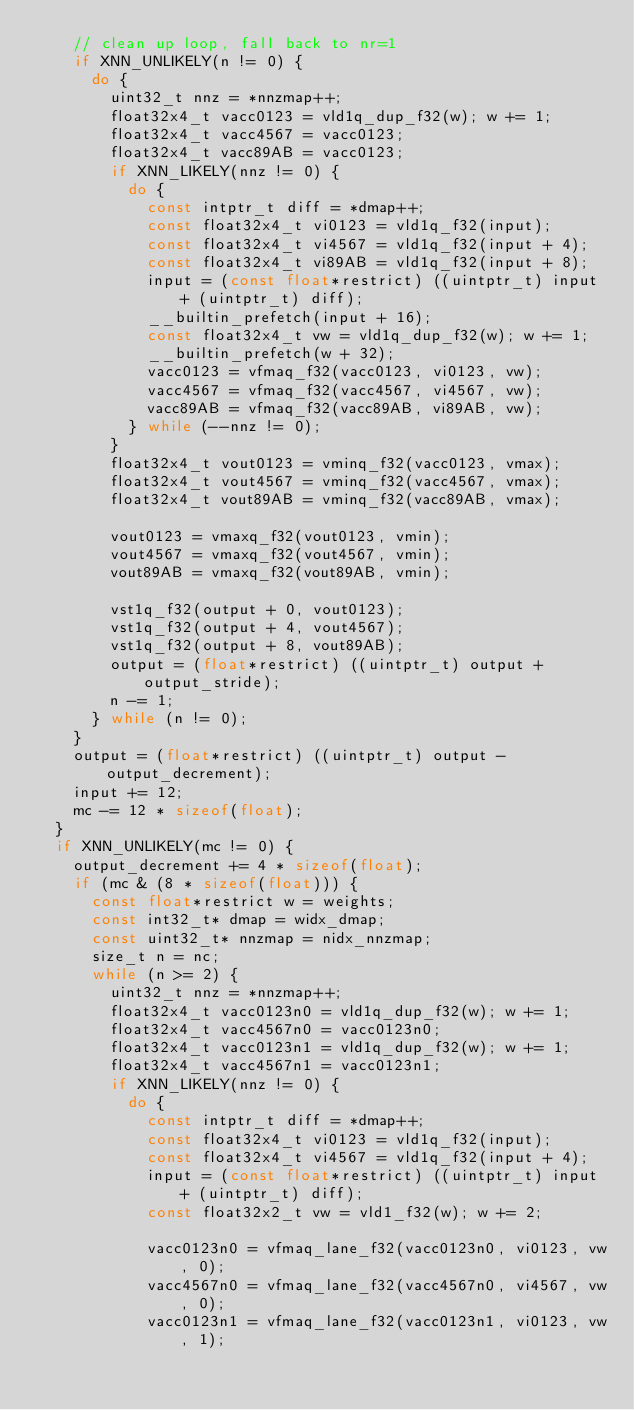Convert code to text. <code><loc_0><loc_0><loc_500><loc_500><_C_>    // clean up loop, fall back to nr=1
    if XNN_UNLIKELY(n != 0) {
      do {
        uint32_t nnz = *nnzmap++;
        float32x4_t vacc0123 = vld1q_dup_f32(w); w += 1;
        float32x4_t vacc4567 = vacc0123;
        float32x4_t vacc89AB = vacc0123;
        if XNN_LIKELY(nnz != 0) {
          do {
            const intptr_t diff = *dmap++;
            const float32x4_t vi0123 = vld1q_f32(input);
            const float32x4_t vi4567 = vld1q_f32(input + 4);
            const float32x4_t vi89AB = vld1q_f32(input + 8);
            input = (const float*restrict) ((uintptr_t) input + (uintptr_t) diff);
            __builtin_prefetch(input + 16);
            const float32x4_t vw = vld1q_dup_f32(w); w += 1;
            __builtin_prefetch(w + 32);
            vacc0123 = vfmaq_f32(vacc0123, vi0123, vw);
            vacc4567 = vfmaq_f32(vacc4567, vi4567, vw);
            vacc89AB = vfmaq_f32(vacc89AB, vi89AB, vw);
          } while (--nnz != 0);
        }
        float32x4_t vout0123 = vminq_f32(vacc0123, vmax);
        float32x4_t vout4567 = vminq_f32(vacc4567, vmax);
        float32x4_t vout89AB = vminq_f32(vacc89AB, vmax);

        vout0123 = vmaxq_f32(vout0123, vmin);
        vout4567 = vmaxq_f32(vout4567, vmin);
        vout89AB = vmaxq_f32(vout89AB, vmin);

        vst1q_f32(output + 0, vout0123);
        vst1q_f32(output + 4, vout4567);
        vst1q_f32(output + 8, vout89AB);
        output = (float*restrict) ((uintptr_t) output + output_stride);
        n -= 1;
      } while (n != 0);
    }
    output = (float*restrict) ((uintptr_t) output - output_decrement);
    input += 12;
    mc -= 12 * sizeof(float);
  }
  if XNN_UNLIKELY(mc != 0) {
    output_decrement += 4 * sizeof(float);
    if (mc & (8 * sizeof(float))) {
      const float*restrict w = weights;
      const int32_t* dmap = widx_dmap;
      const uint32_t* nnzmap = nidx_nnzmap;
      size_t n = nc;
      while (n >= 2) {
        uint32_t nnz = *nnzmap++;
        float32x4_t vacc0123n0 = vld1q_dup_f32(w); w += 1;
        float32x4_t vacc4567n0 = vacc0123n0;
        float32x4_t vacc0123n1 = vld1q_dup_f32(w); w += 1;
        float32x4_t vacc4567n1 = vacc0123n1;
        if XNN_LIKELY(nnz != 0) {
          do {
            const intptr_t diff = *dmap++;
            const float32x4_t vi0123 = vld1q_f32(input);
            const float32x4_t vi4567 = vld1q_f32(input + 4);
            input = (const float*restrict) ((uintptr_t) input + (uintptr_t) diff);
            const float32x2_t vw = vld1_f32(w); w += 2;

            vacc0123n0 = vfmaq_lane_f32(vacc0123n0, vi0123, vw, 0);
            vacc4567n0 = vfmaq_lane_f32(vacc4567n0, vi4567, vw, 0);
            vacc0123n1 = vfmaq_lane_f32(vacc0123n1, vi0123, vw, 1);</code> 